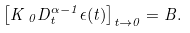Convert formula to latex. <formula><loc_0><loc_0><loc_500><loc_500>\left [ K \, _ { 0 } D _ { t } ^ { \alpha - 1 } \epsilon ( t ) \right ] _ { t \rightarrow 0 } = B .</formula> 